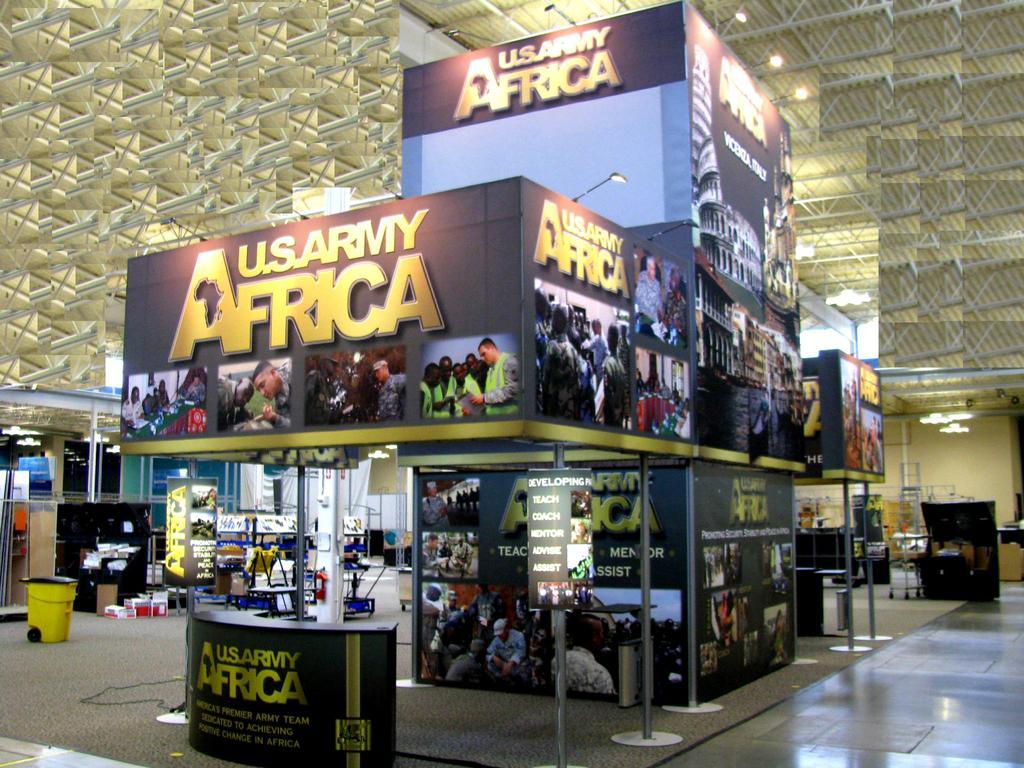Please provide a concise description of this image. this image is clicked inside a room. In the center is a store. There are boards with text and pictures. At the background there is a ceiling. There are lights to the ceiling. In the foreground there is a table. To the left there is a dustbin 